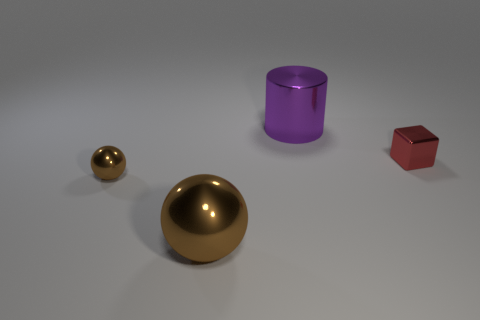Add 3 big green matte objects. How many objects exist? 7 Subtract all blocks. How many objects are left? 3 Add 1 large cubes. How many large cubes exist? 1 Subtract 0 brown cubes. How many objects are left? 4 Subtract all red cubes. Subtract all blue balls. How many objects are left? 3 Add 4 shiny cubes. How many shiny cubes are left? 5 